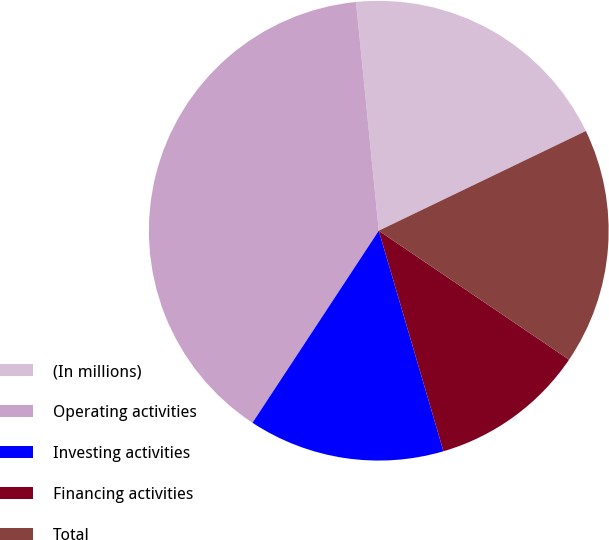Convert chart to OTSL. <chart><loc_0><loc_0><loc_500><loc_500><pie_chart><fcel>(In millions)<fcel>Operating activities<fcel>Investing activities<fcel>Financing activities<fcel>Total<nl><fcel>19.44%<fcel>39.17%<fcel>13.8%<fcel>10.98%<fcel>16.62%<nl></chart> 